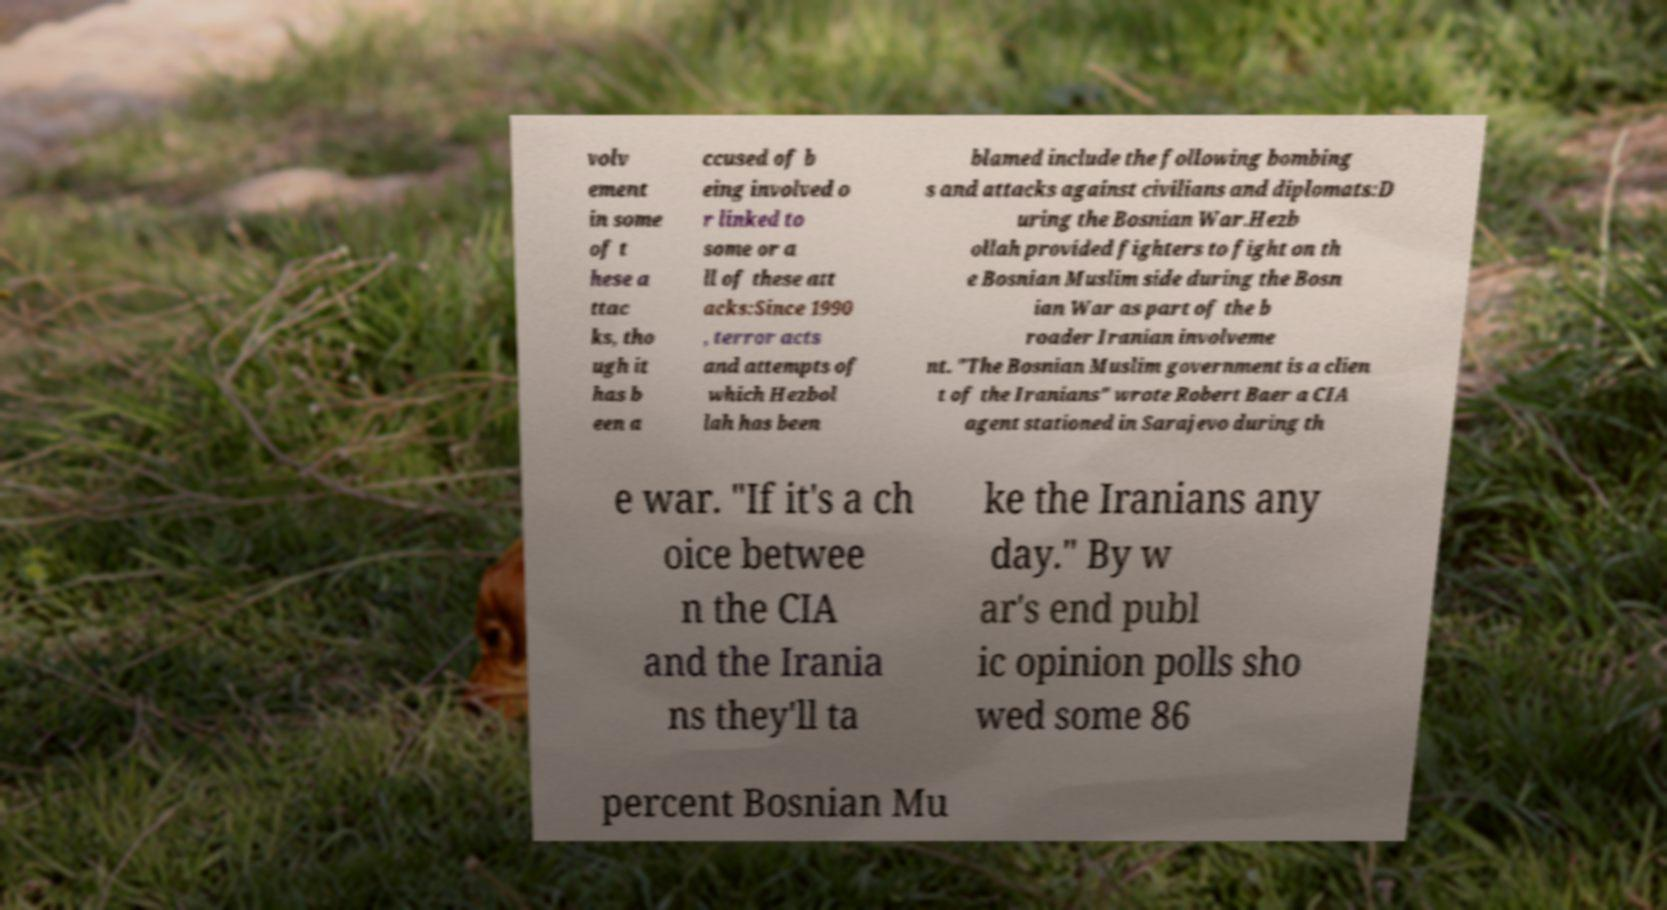Could you assist in decoding the text presented in this image and type it out clearly? volv ement in some of t hese a ttac ks, tho ugh it has b een a ccused of b eing involved o r linked to some or a ll of these att acks:Since 1990 , terror acts and attempts of which Hezbol lah has been blamed include the following bombing s and attacks against civilians and diplomats:D uring the Bosnian War.Hezb ollah provided fighters to fight on th e Bosnian Muslim side during the Bosn ian War as part of the b roader Iranian involveme nt. "The Bosnian Muslim government is a clien t of the Iranians" wrote Robert Baer a CIA agent stationed in Sarajevo during th e war. "If it's a ch oice betwee n the CIA and the Irania ns they'll ta ke the Iranians any day." By w ar's end publ ic opinion polls sho wed some 86 percent Bosnian Mu 